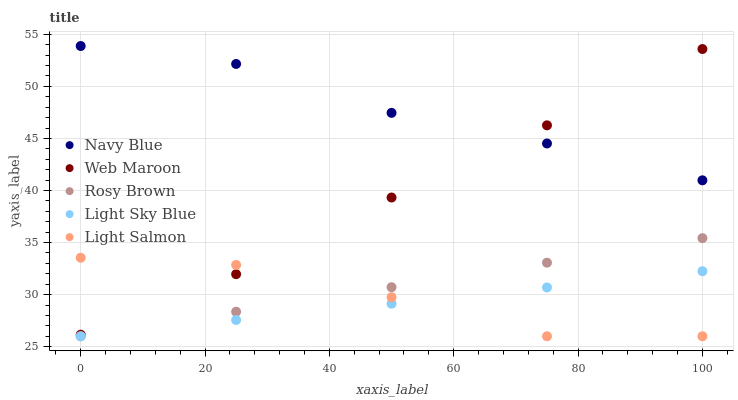Does Light Sky Blue have the minimum area under the curve?
Answer yes or no. Yes. Does Navy Blue have the maximum area under the curve?
Answer yes or no. Yes. Does Light Salmon have the minimum area under the curve?
Answer yes or no. No. Does Light Salmon have the maximum area under the curve?
Answer yes or no. No. Is Light Sky Blue the smoothest?
Answer yes or no. Yes. Is Light Salmon the roughest?
Answer yes or no. Yes. Is Rosy Brown the smoothest?
Answer yes or no. No. Is Rosy Brown the roughest?
Answer yes or no. No. Does Light Salmon have the lowest value?
Answer yes or no. Yes. Does Web Maroon have the lowest value?
Answer yes or no. No. Does Navy Blue have the highest value?
Answer yes or no. Yes. Does Light Salmon have the highest value?
Answer yes or no. No. Is Rosy Brown less than Navy Blue?
Answer yes or no. Yes. Is Navy Blue greater than Light Salmon?
Answer yes or no. Yes. Does Light Sky Blue intersect Rosy Brown?
Answer yes or no. Yes. Is Light Sky Blue less than Rosy Brown?
Answer yes or no. No. Is Light Sky Blue greater than Rosy Brown?
Answer yes or no. No. Does Rosy Brown intersect Navy Blue?
Answer yes or no. No. 